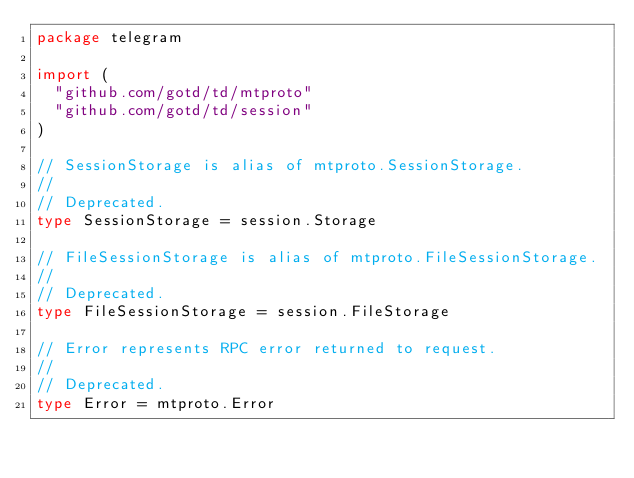<code> <loc_0><loc_0><loc_500><loc_500><_Go_>package telegram

import (
	"github.com/gotd/td/mtproto"
	"github.com/gotd/td/session"
)

// SessionStorage is alias of mtproto.SessionStorage.
//
// Deprecated.
type SessionStorage = session.Storage

// FileSessionStorage is alias of mtproto.FileSessionStorage.
//
// Deprecated.
type FileSessionStorage = session.FileStorage

// Error represents RPC error returned to request.
//
// Deprecated.
type Error = mtproto.Error
</code> 